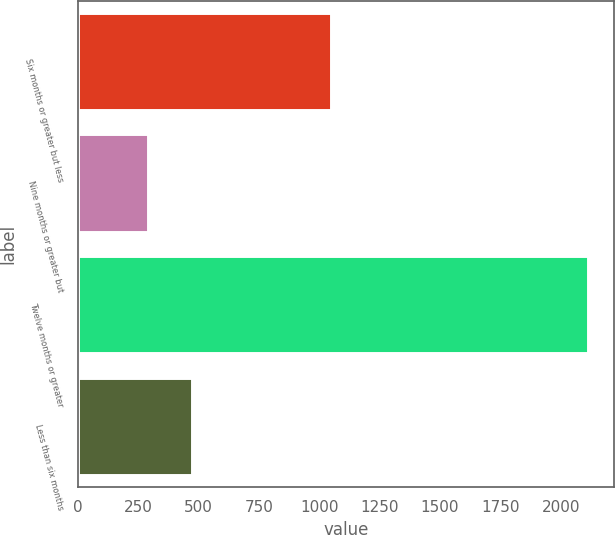Convert chart. <chart><loc_0><loc_0><loc_500><loc_500><bar_chart><fcel>Six months or greater but less<fcel>Nine months or greater but<fcel>Twelve months or greater<fcel>Less than six months<nl><fcel>1049<fcel>288<fcel>2115<fcel>470.7<nl></chart> 